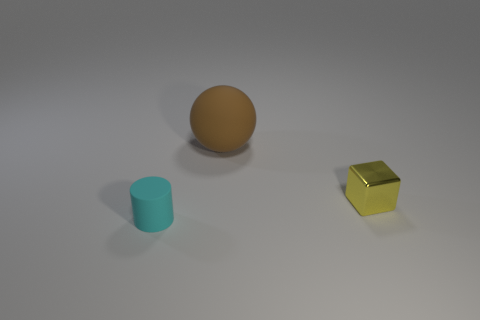Are there any other things that are the same shape as the small shiny thing?
Ensure brevity in your answer.  No. Are there the same number of cyan cylinders on the right side of the small cyan object and gray metallic objects?
Offer a terse response. Yes. What number of small things are both left of the metal object and to the right of the big brown matte object?
Your answer should be very brief. 0. What number of big brown balls have the same material as the small yellow thing?
Your answer should be compact. 0. Is the number of brown balls on the left side of the matte ball less than the number of tiny yellow metallic things?
Ensure brevity in your answer.  Yes. How many big objects are there?
Keep it short and to the point. 1. How many tiny matte cylinders are the same color as the large ball?
Give a very brief answer. 0. Do the shiny thing and the tiny cyan matte object have the same shape?
Offer a terse response. No. What size is the rubber object behind the rubber thing in front of the big brown matte ball?
Your answer should be compact. Large. Are there any other cyan cylinders that have the same size as the cyan rubber cylinder?
Your answer should be compact. No. 